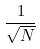<formula> <loc_0><loc_0><loc_500><loc_500>\frac { 1 } { \sqrt { N } }</formula> 